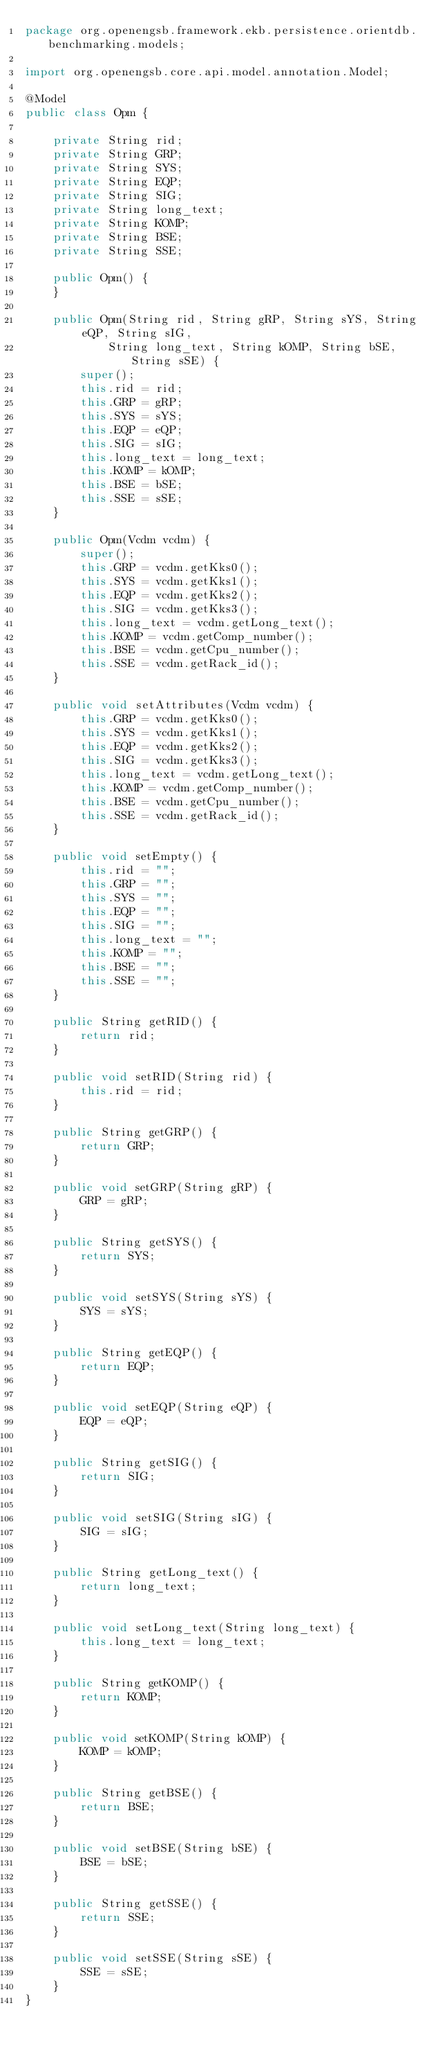<code> <loc_0><loc_0><loc_500><loc_500><_Java_>package org.openengsb.framework.ekb.persistence.orientdb.benchmarking.models;

import org.openengsb.core.api.model.annotation.Model;

@Model
public class Opm {

    private String rid;
    private String GRP;
    private String SYS;
    private String EQP;
    private String SIG;
    private String long_text;
    private String KOMP;
    private String BSE;
    private String SSE;

    public Opm() {
    }

    public Opm(String rid, String gRP, String sYS, String eQP, String sIG,
            String long_text, String kOMP, String bSE, String sSE) {
        super();
        this.rid = rid;
        this.GRP = gRP;
        this.SYS = sYS;
        this.EQP = eQP;
        this.SIG = sIG;
        this.long_text = long_text;
        this.KOMP = kOMP;
        this.BSE = bSE;
        this.SSE = sSE;
    }

    public Opm(Vcdm vcdm) {
        super();
        this.GRP = vcdm.getKks0();
        this.SYS = vcdm.getKks1();
        this.EQP = vcdm.getKks2();
        this.SIG = vcdm.getKks3();
        this.long_text = vcdm.getLong_text();
        this.KOMP = vcdm.getComp_number();
        this.BSE = vcdm.getCpu_number();
        this.SSE = vcdm.getRack_id();
    }

    public void setAttributes(Vcdm vcdm) {
        this.GRP = vcdm.getKks0();
        this.SYS = vcdm.getKks1();
        this.EQP = vcdm.getKks2();
        this.SIG = vcdm.getKks3();
        this.long_text = vcdm.getLong_text();
        this.KOMP = vcdm.getComp_number();
        this.BSE = vcdm.getCpu_number();
        this.SSE = vcdm.getRack_id();
    }

    public void setEmpty() {
        this.rid = "";
        this.GRP = "";
        this.SYS = "";
        this.EQP = "";
        this.SIG = "";
        this.long_text = "";
        this.KOMP = "";
        this.BSE = "";
        this.SSE = "";
    }

    public String getRID() {
        return rid;
    }

    public void setRID(String rid) {
        this.rid = rid;
    }

    public String getGRP() {
        return GRP;
    }

    public void setGRP(String gRP) {
        GRP = gRP;
    }

    public String getSYS() {
        return SYS;
    }

    public void setSYS(String sYS) {
        SYS = sYS;
    }

    public String getEQP() {
        return EQP;
    }

    public void setEQP(String eQP) {
        EQP = eQP;
    }

    public String getSIG() {
        return SIG;
    }

    public void setSIG(String sIG) {
        SIG = sIG;
    }

    public String getLong_text() {
        return long_text;
    }

    public void setLong_text(String long_text) {
        this.long_text = long_text;
    }

    public String getKOMP() {
        return KOMP;
    }

    public void setKOMP(String kOMP) {
        KOMP = kOMP;
    }

    public String getBSE() {
        return BSE;
    }

    public void setBSE(String bSE) {
        BSE = bSE;
    }

    public String getSSE() {
        return SSE;
    }

    public void setSSE(String sSE) {
        SSE = sSE;
    }
}
</code> 